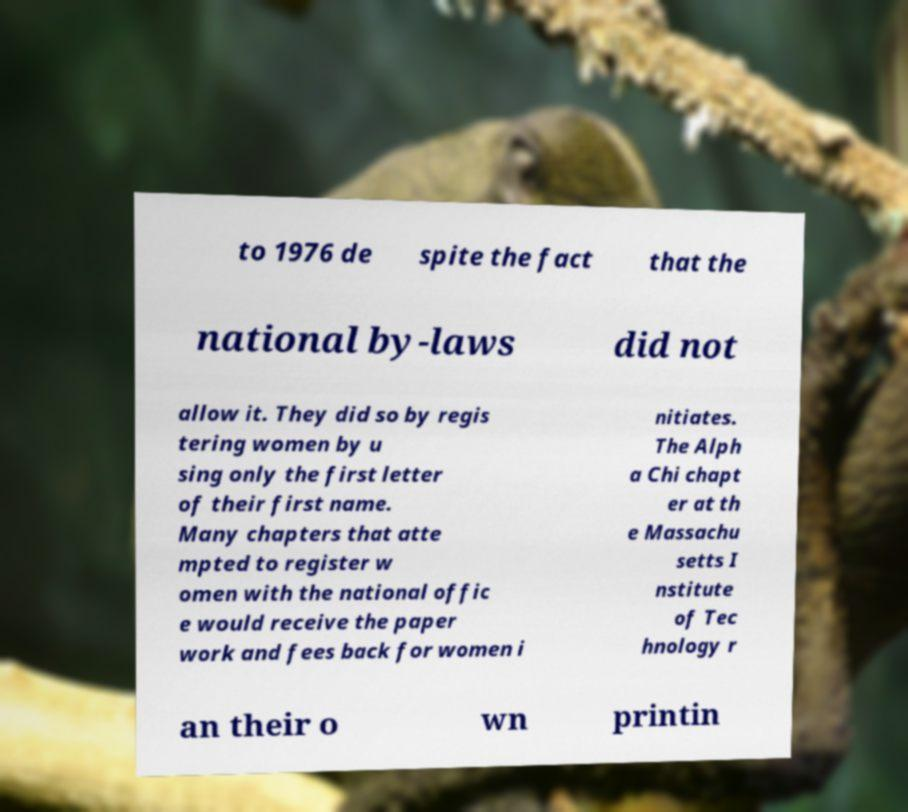Can you read and provide the text displayed in the image?This photo seems to have some interesting text. Can you extract and type it out for me? to 1976 de spite the fact that the national by-laws did not allow it. They did so by regis tering women by u sing only the first letter of their first name. Many chapters that atte mpted to register w omen with the national offic e would receive the paper work and fees back for women i nitiates. The Alph a Chi chapt er at th e Massachu setts I nstitute of Tec hnology r an their o wn printin 